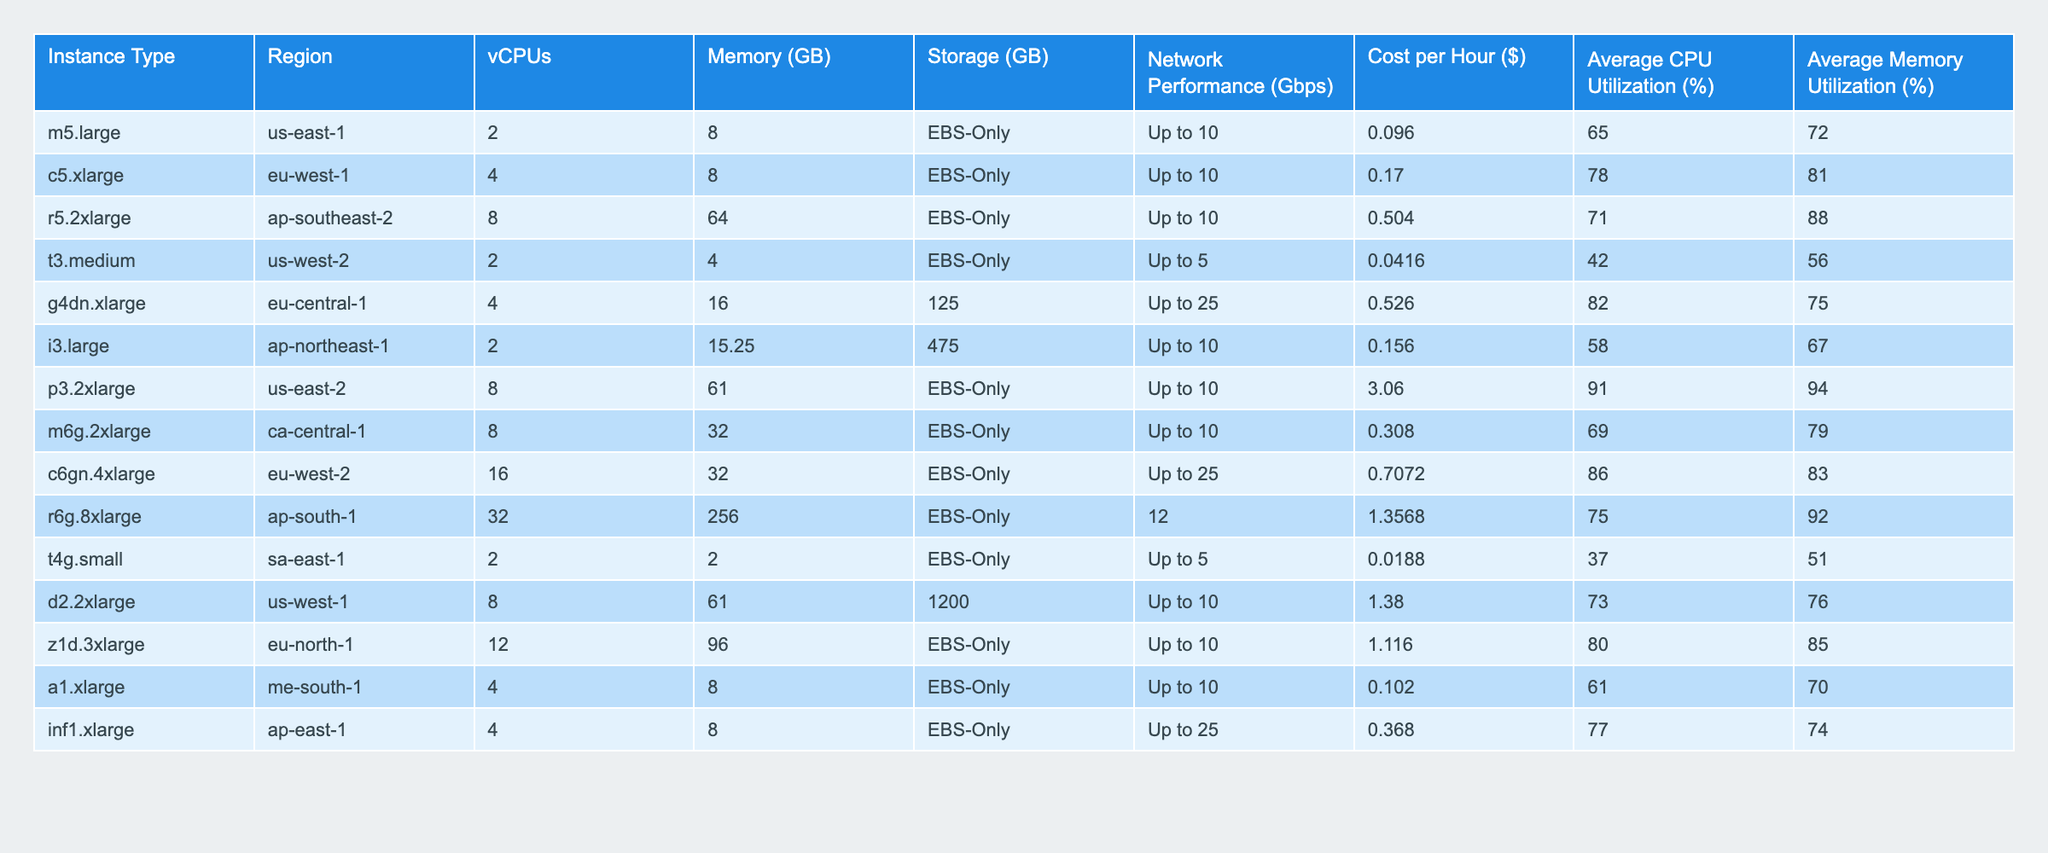What is the cost per hour for the r5.2xlarge instance type? The table shows the cost associated with each instance type. For r5.2xlarge, the cost per hour is listed directly in the table.
Answer: 0.504 Which instance type has the highest average CPU utilization? Looking through the average CPU utilization column, the p3.2xlarge instance type has the highest value at 91%.
Answer: p3.2xlarge What is the total memory (in GB) of all instances listed in the table? By adding the memory values: (8 + 8 + 64 + 4 + 16 + 15.25 + 61 + 32 + 256 + 2 + 61 + 96 + 8 + 8) = 530.
Answer: 530 Is the average memory utilization for the g4dn.xlarge instance type higher than 70%? The average memory utilization for g4dn.xlarge is listed at 75%, which is indeed higher than 70%.
Answer: Yes Which instance type has the lowest cost per hour, and what is that cost? By scanning the cost column, t4g.small has the lowest cost at 0.0188 per hour.
Answer: t4g.small, 0.0188 What is the difference in cost per hour between the most expensive and least expensive instance types? The most expensive instance is p3.2xlarge at 3.06, and the least expensive is t4g.small at 0.0188. Calculating the difference: 3.06 - 0.0188 = 3.0412.
Answer: 3.0412 Are there more instance types located in the US regions than in the EU regions? Counting the rows, there are 5 instance types in the US and 4 in the EU (including the UK). Therefore, the count of US instance types is higher.
Answer: Yes What is the average cost per hour of the instances with a network performance greater than 10 Gbps? The only relevant instance has a network performance of 12 Gbps, which is the r6g.8xlarge, costing 1.3568 per hour. Since it’s the only instance, the average is the same: 1.3568.
Answer: 1.3568 Which regions have instances with a memory utilization of over 80%? Looking through the average memory utilization column, the regions with values greater than 80% are ap-southeast-2, us-east-2, eu-west-2, and ap-south-1.
Answer: ap-southeast-2, us-east-2, eu-west-2, ap-south-1 What is the ratio of vCPUs to average CPU utilization for the c5.xlarge instance type? For c5.xlarge, there are 4 vCPUs and average CPU utilization is 78%. The ratio is calculated as 4 / 78 = 0.0513 (after conversion to the same unit to compare).
Answer: 0.0513 